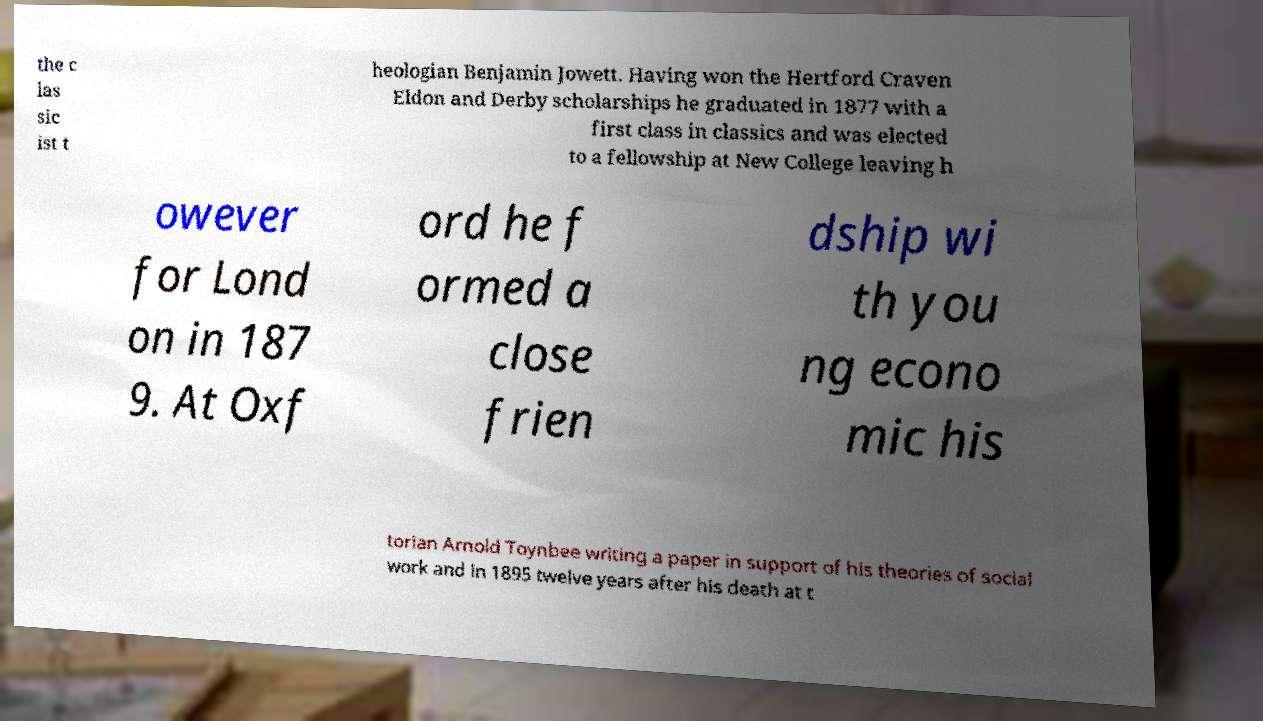I need the written content from this picture converted into text. Can you do that? the c las sic ist t heologian Benjamin Jowett. Having won the Hertford Craven Eldon and Derby scholarships he graduated in 1877 with a first class in classics and was elected to a fellowship at New College leaving h owever for Lond on in 187 9. At Oxf ord he f ormed a close frien dship wi th you ng econo mic his torian Arnold Toynbee writing a paper in support of his theories of social work and in 1895 twelve years after his death at t 